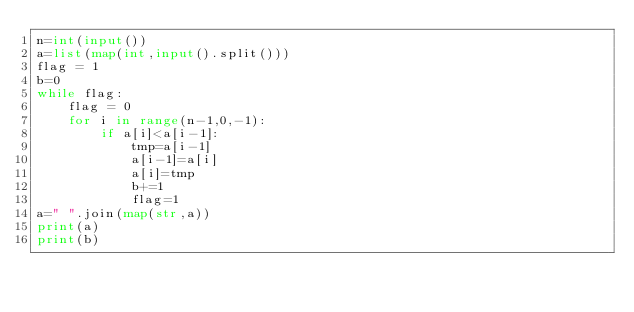<code> <loc_0><loc_0><loc_500><loc_500><_Python_>n=int(input())
a=list(map(int,input().split()))
flag = 1
b=0
while flag:
    flag = 0
    for i in range(n-1,0,-1):
        if a[i]<a[i-1]:
            tmp=a[i-1]
            a[i-1]=a[i]
            a[i]=tmp
            b+=1
            flag=1
a=" ".join(map(str,a))
print(a)
print(b)
</code> 